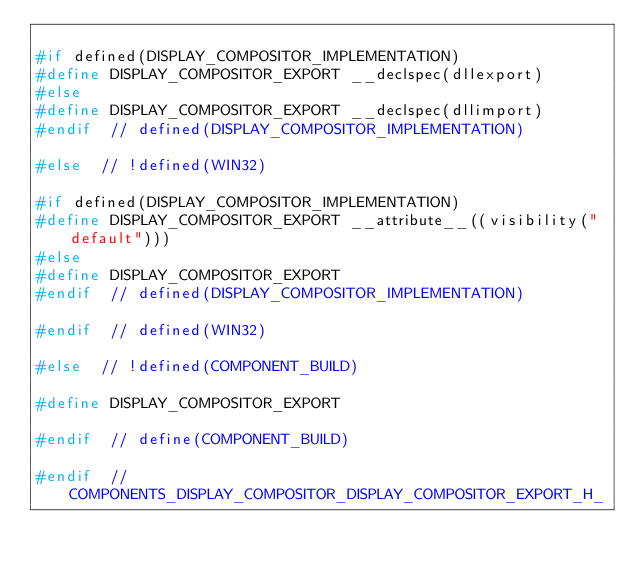Convert code to text. <code><loc_0><loc_0><loc_500><loc_500><_C_>
#if defined(DISPLAY_COMPOSITOR_IMPLEMENTATION)
#define DISPLAY_COMPOSITOR_EXPORT __declspec(dllexport)
#else
#define DISPLAY_COMPOSITOR_EXPORT __declspec(dllimport)
#endif  // defined(DISPLAY_COMPOSITOR_IMPLEMENTATION)

#else  // !defined(WIN32)

#if defined(DISPLAY_COMPOSITOR_IMPLEMENTATION)
#define DISPLAY_COMPOSITOR_EXPORT __attribute__((visibility("default")))
#else
#define DISPLAY_COMPOSITOR_EXPORT
#endif  // defined(DISPLAY_COMPOSITOR_IMPLEMENTATION)

#endif  // defined(WIN32)

#else  // !defined(COMPONENT_BUILD)

#define DISPLAY_COMPOSITOR_EXPORT

#endif  // define(COMPONENT_BUILD)

#endif  // COMPONENTS_DISPLAY_COMPOSITOR_DISPLAY_COMPOSITOR_EXPORT_H_
</code> 